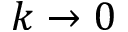Convert formula to latex. <formula><loc_0><loc_0><loc_500><loc_500>k \rightarrow 0</formula> 